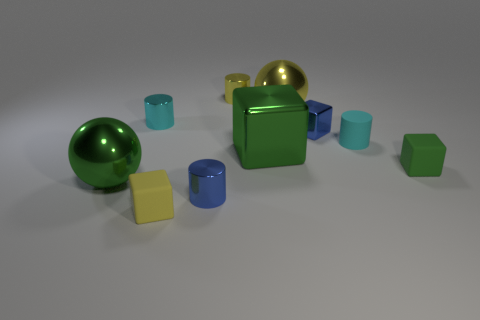Could you describe the lighting in the scene? The lighting in the scene is soft and diffused, casting gentle shadows beneath the objects. It appears to be coming from above, as indicated by the direction of the shadows, providing an even illumination to the entire scene. 